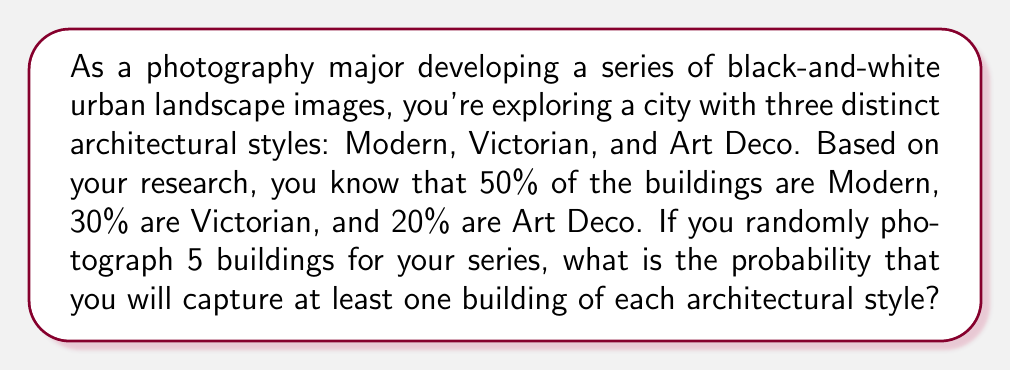Solve this math problem. To solve this problem, we'll use the complement method:

1) First, let's calculate the probability of not getting at least one of each style. This is equivalent to the probability of missing at least one style.

2) We can break this down into three scenarios:
   a) No Victorian buildings
   b) No Art Deco buildings
   c) No Modern buildings

3) Let's calculate each:

   a) Probability of no Victorian buildings:
      $P(\text{no Victorian}) = (0.5 + 0.2)^5 = 0.7^5 \approx 0.16807$

   b) Probability of no Art Deco buildings:
      $P(\text{no Art Deco}) = (0.5 + 0.3)^5 = 0.8^5 = 0.32768$

   c) Probability of no Modern buildings:
      $P(\text{no Modern}) = (0.3 + 0.2)^5 = 0.5^5 = 0.03125$

4) Now, we need to add these probabilities, but we've overcounted some scenarios. We need to use the Inclusion-Exclusion Principle:

   $P(\text{miss at least one}) = P(A \cup B \cup C) = P(A) + P(B) + P(C) - P(A \cap B) - P(A \cap C) - P(B \cap C) + P(A \cap B \cap C)$

   Where A, B, and C represent the events of missing Victorian, Art Deco, and Modern styles respectively.

5) We've calculated P(A), P(B), and P(C). Now let's calculate the intersections:

   $P(A \cap B) = 0.2^5 = 0.00032$
   $P(A \cap C) = 0.3^5 = 0.00243$
   $P(B \cap C) = 0.5^5 = 0.03125$
   $P(A \cap B \cap C) = 0$

6) Putting it all together:

   $P(\text{miss at least one}) = 0.16807 + 0.32768 + 0.03125 - 0.00032 - 0.00243 - 0.03125 + 0 = 0.493$

7) Therefore, the probability of getting at least one of each style is:

   $P(\text{at least one of each}) = 1 - P(\text{miss at least one}) = 1 - 0.493 = 0.507$
Answer: The probability of capturing at least one building of each architectural style when randomly photographing 5 buildings is approximately 0.507 or 50.7%. 